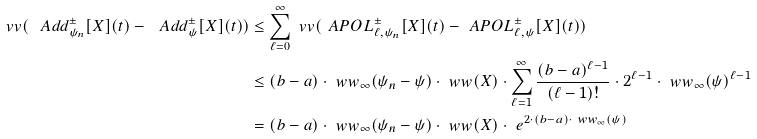<formula> <loc_0><loc_0><loc_500><loc_500>\ v v ( \ A d d ^ { \pm } _ { \psi _ { n } } [ X ] ( t ) - \ A d d ^ { \pm } _ { \psi } [ X ] ( t ) ) & \leq \sum _ { \ell = 0 } ^ { \infty } \ v v ( \ A P O L ^ { \pm } _ { \ell , \psi _ { n } } [ X ] ( t ) - \ A P O L ^ { \pm } _ { \ell , \psi } [ X ] ( t ) ) \\ & \leq ( b - a ) \cdot \ w w _ { \infty } ( \psi _ { n } - \psi ) \cdot \ w w ( X ) \cdot \sum _ { \ell = 1 } ^ { \infty } \frac { ( b - a ) ^ { \ell - 1 } } { ( \ell - 1 ) ! } \cdot 2 ^ { \ell - 1 } \cdot \ w w _ { \infty } ( \psi ) ^ { \ell - 1 } \\ & = ( b - a ) \cdot \ w w _ { \infty } ( \psi _ { n } - \psi ) \cdot \ w w ( X ) \cdot \ e ^ { 2 \cdot ( b - a ) \cdot \ w w _ { \infty } ( \psi ) }</formula> 